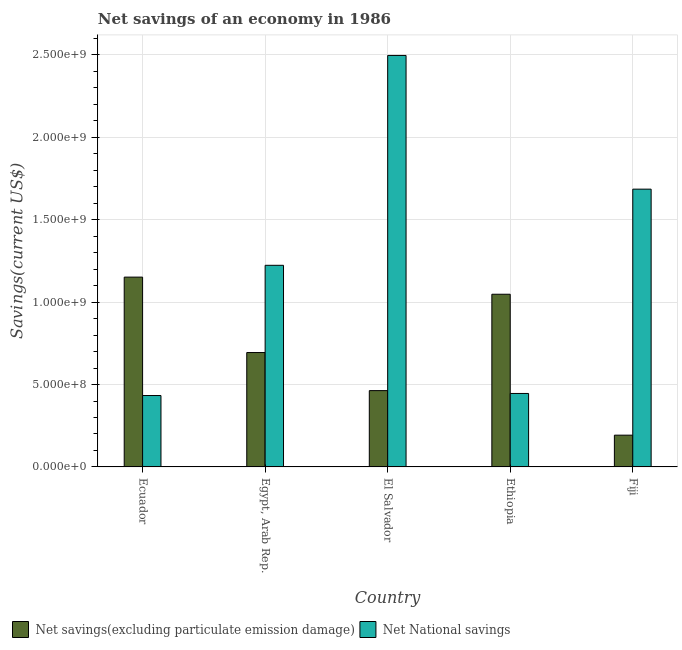How many groups of bars are there?
Keep it short and to the point. 5. How many bars are there on the 1st tick from the left?
Your response must be concise. 2. How many bars are there on the 2nd tick from the right?
Provide a short and direct response. 2. What is the label of the 4th group of bars from the left?
Provide a short and direct response. Ethiopia. In how many cases, is the number of bars for a given country not equal to the number of legend labels?
Your answer should be compact. 0. What is the net national savings in Ecuador?
Ensure brevity in your answer.  4.33e+08. Across all countries, what is the maximum net savings(excluding particulate emission damage)?
Ensure brevity in your answer.  1.15e+09. Across all countries, what is the minimum net national savings?
Your response must be concise. 4.33e+08. In which country was the net national savings maximum?
Offer a very short reply. El Salvador. In which country was the net savings(excluding particulate emission damage) minimum?
Offer a terse response. Fiji. What is the total net savings(excluding particulate emission damage) in the graph?
Keep it short and to the point. 3.55e+09. What is the difference between the net national savings in Egypt, Arab Rep. and that in El Salvador?
Provide a succinct answer. -1.27e+09. What is the difference between the net national savings in Fiji and the net savings(excluding particulate emission damage) in Egypt, Arab Rep.?
Offer a terse response. 9.91e+08. What is the average net national savings per country?
Provide a short and direct response. 1.26e+09. What is the difference between the net savings(excluding particulate emission damage) and net national savings in El Salvador?
Your answer should be very brief. -2.03e+09. What is the ratio of the net savings(excluding particulate emission damage) in Egypt, Arab Rep. to that in Fiji?
Your answer should be very brief. 3.6. Is the net national savings in Egypt, Arab Rep. less than that in Ethiopia?
Provide a short and direct response. No. What is the difference between the highest and the second highest net savings(excluding particulate emission damage)?
Provide a short and direct response. 1.04e+08. What is the difference between the highest and the lowest net savings(excluding particulate emission damage)?
Ensure brevity in your answer.  9.59e+08. In how many countries, is the net national savings greater than the average net national savings taken over all countries?
Keep it short and to the point. 2. What does the 2nd bar from the left in El Salvador represents?
Offer a very short reply. Net National savings. What does the 2nd bar from the right in Ecuador represents?
Your answer should be very brief. Net savings(excluding particulate emission damage). Are all the bars in the graph horizontal?
Your answer should be very brief. No. Are the values on the major ticks of Y-axis written in scientific E-notation?
Give a very brief answer. Yes. Where does the legend appear in the graph?
Your answer should be compact. Bottom left. What is the title of the graph?
Provide a short and direct response. Net savings of an economy in 1986. What is the label or title of the Y-axis?
Provide a short and direct response. Savings(current US$). What is the Savings(current US$) in Net savings(excluding particulate emission damage) in Ecuador?
Your answer should be very brief. 1.15e+09. What is the Savings(current US$) of Net National savings in Ecuador?
Offer a terse response. 4.33e+08. What is the Savings(current US$) of Net savings(excluding particulate emission damage) in Egypt, Arab Rep.?
Ensure brevity in your answer.  6.94e+08. What is the Savings(current US$) in Net National savings in Egypt, Arab Rep.?
Provide a short and direct response. 1.22e+09. What is the Savings(current US$) of Net savings(excluding particulate emission damage) in El Salvador?
Keep it short and to the point. 4.63e+08. What is the Savings(current US$) of Net National savings in El Salvador?
Your answer should be compact. 2.50e+09. What is the Savings(current US$) of Net savings(excluding particulate emission damage) in Ethiopia?
Your answer should be very brief. 1.05e+09. What is the Savings(current US$) in Net National savings in Ethiopia?
Offer a terse response. 4.46e+08. What is the Savings(current US$) in Net savings(excluding particulate emission damage) in Fiji?
Your answer should be very brief. 1.93e+08. What is the Savings(current US$) in Net National savings in Fiji?
Offer a very short reply. 1.69e+09. Across all countries, what is the maximum Savings(current US$) of Net savings(excluding particulate emission damage)?
Provide a succinct answer. 1.15e+09. Across all countries, what is the maximum Savings(current US$) of Net National savings?
Offer a terse response. 2.50e+09. Across all countries, what is the minimum Savings(current US$) of Net savings(excluding particulate emission damage)?
Ensure brevity in your answer.  1.93e+08. Across all countries, what is the minimum Savings(current US$) in Net National savings?
Your answer should be very brief. 4.33e+08. What is the total Savings(current US$) of Net savings(excluding particulate emission damage) in the graph?
Your answer should be compact. 3.55e+09. What is the total Savings(current US$) of Net National savings in the graph?
Provide a short and direct response. 6.28e+09. What is the difference between the Savings(current US$) in Net savings(excluding particulate emission damage) in Ecuador and that in Egypt, Arab Rep.?
Provide a succinct answer. 4.58e+08. What is the difference between the Savings(current US$) in Net National savings in Ecuador and that in Egypt, Arab Rep.?
Offer a terse response. -7.90e+08. What is the difference between the Savings(current US$) in Net savings(excluding particulate emission damage) in Ecuador and that in El Salvador?
Provide a short and direct response. 6.89e+08. What is the difference between the Savings(current US$) in Net National savings in Ecuador and that in El Salvador?
Ensure brevity in your answer.  -2.06e+09. What is the difference between the Savings(current US$) of Net savings(excluding particulate emission damage) in Ecuador and that in Ethiopia?
Offer a terse response. 1.04e+08. What is the difference between the Savings(current US$) of Net National savings in Ecuador and that in Ethiopia?
Ensure brevity in your answer.  -1.25e+07. What is the difference between the Savings(current US$) in Net savings(excluding particulate emission damage) in Ecuador and that in Fiji?
Give a very brief answer. 9.59e+08. What is the difference between the Savings(current US$) of Net National savings in Ecuador and that in Fiji?
Offer a terse response. -1.25e+09. What is the difference between the Savings(current US$) of Net savings(excluding particulate emission damage) in Egypt, Arab Rep. and that in El Salvador?
Offer a very short reply. 2.31e+08. What is the difference between the Savings(current US$) in Net National savings in Egypt, Arab Rep. and that in El Salvador?
Ensure brevity in your answer.  -1.27e+09. What is the difference between the Savings(current US$) in Net savings(excluding particulate emission damage) in Egypt, Arab Rep. and that in Ethiopia?
Ensure brevity in your answer.  -3.54e+08. What is the difference between the Savings(current US$) in Net National savings in Egypt, Arab Rep. and that in Ethiopia?
Your response must be concise. 7.78e+08. What is the difference between the Savings(current US$) in Net savings(excluding particulate emission damage) in Egypt, Arab Rep. and that in Fiji?
Your answer should be compact. 5.01e+08. What is the difference between the Savings(current US$) in Net National savings in Egypt, Arab Rep. and that in Fiji?
Offer a terse response. -4.62e+08. What is the difference between the Savings(current US$) of Net savings(excluding particulate emission damage) in El Salvador and that in Ethiopia?
Ensure brevity in your answer.  -5.85e+08. What is the difference between the Savings(current US$) of Net National savings in El Salvador and that in Ethiopia?
Your response must be concise. 2.05e+09. What is the difference between the Savings(current US$) of Net savings(excluding particulate emission damage) in El Salvador and that in Fiji?
Provide a short and direct response. 2.70e+08. What is the difference between the Savings(current US$) of Net National savings in El Salvador and that in Fiji?
Make the answer very short. 8.11e+08. What is the difference between the Savings(current US$) of Net savings(excluding particulate emission damage) in Ethiopia and that in Fiji?
Provide a succinct answer. 8.55e+08. What is the difference between the Savings(current US$) in Net National savings in Ethiopia and that in Fiji?
Offer a terse response. -1.24e+09. What is the difference between the Savings(current US$) in Net savings(excluding particulate emission damage) in Ecuador and the Savings(current US$) in Net National savings in Egypt, Arab Rep.?
Give a very brief answer. -7.17e+07. What is the difference between the Savings(current US$) in Net savings(excluding particulate emission damage) in Ecuador and the Savings(current US$) in Net National savings in El Salvador?
Your answer should be compact. -1.34e+09. What is the difference between the Savings(current US$) of Net savings(excluding particulate emission damage) in Ecuador and the Savings(current US$) of Net National savings in Ethiopia?
Ensure brevity in your answer.  7.06e+08. What is the difference between the Savings(current US$) of Net savings(excluding particulate emission damage) in Ecuador and the Savings(current US$) of Net National savings in Fiji?
Offer a terse response. -5.34e+08. What is the difference between the Savings(current US$) in Net savings(excluding particulate emission damage) in Egypt, Arab Rep. and the Savings(current US$) in Net National savings in El Salvador?
Ensure brevity in your answer.  -1.80e+09. What is the difference between the Savings(current US$) of Net savings(excluding particulate emission damage) in Egypt, Arab Rep. and the Savings(current US$) of Net National savings in Ethiopia?
Your response must be concise. 2.48e+08. What is the difference between the Savings(current US$) of Net savings(excluding particulate emission damage) in Egypt, Arab Rep. and the Savings(current US$) of Net National savings in Fiji?
Make the answer very short. -9.91e+08. What is the difference between the Savings(current US$) of Net savings(excluding particulate emission damage) in El Salvador and the Savings(current US$) of Net National savings in Ethiopia?
Make the answer very short. 1.73e+07. What is the difference between the Savings(current US$) of Net savings(excluding particulate emission damage) in El Salvador and the Savings(current US$) of Net National savings in Fiji?
Provide a succinct answer. -1.22e+09. What is the difference between the Savings(current US$) of Net savings(excluding particulate emission damage) in Ethiopia and the Savings(current US$) of Net National savings in Fiji?
Make the answer very short. -6.38e+08. What is the average Savings(current US$) of Net savings(excluding particulate emission damage) per country?
Provide a succinct answer. 7.10e+08. What is the average Savings(current US$) in Net National savings per country?
Offer a terse response. 1.26e+09. What is the difference between the Savings(current US$) in Net savings(excluding particulate emission damage) and Savings(current US$) in Net National savings in Ecuador?
Keep it short and to the point. 7.18e+08. What is the difference between the Savings(current US$) of Net savings(excluding particulate emission damage) and Savings(current US$) of Net National savings in Egypt, Arab Rep.?
Make the answer very short. -5.29e+08. What is the difference between the Savings(current US$) of Net savings(excluding particulate emission damage) and Savings(current US$) of Net National savings in El Salvador?
Ensure brevity in your answer.  -2.03e+09. What is the difference between the Savings(current US$) in Net savings(excluding particulate emission damage) and Savings(current US$) in Net National savings in Ethiopia?
Keep it short and to the point. 6.02e+08. What is the difference between the Savings(current US$) in Net savings(excluding particulate emission damage) and Savings(current US$) in Net National savings in Fiji?
Provide a succinct answer. -1.49e+09. What is the ratio of the Savings(current US$) of Net savings(excluding particulate emission damage) in Ecuador to that in Egypt, Arab Rep.?
Keep it short and to the point. 1.66. What is the ratio of the Savings(current US$) in Net National savings in Ecuador to that in Egypt, Arab Rep.?
Keep it short and to the point. 0.35. What is the ratio of the Savings(current US$) in Net savings(excluding particulate emission damage) in Ecuador to that in El Salvador?
Ensure brevity in your answer.  2.49. What is the ratio of the Savings(current US$) of Net National savings in Ecuador to that in El Salvador?
Your answer should be very brief. 0.17. What is the ratio of the Savings(current US$) of Net savings(excluding particulate emission damage) in Ecuador to that in Ethiopia?
Give a very brief answer. 1.1. What is the ratio of the Savings(current US$) of Net National savings in Ecuador to that in Ethiopia?
Your answer should be compact. 0.97. What is the ratio of the Savings(current US$) in Net savings(excluding particulate emission damage) in Ecuador to that in Fiji?
Provide a succinct answer. 5.98. What is the ratio of the Savings(current US$) in Net National savings in Ecuador to that in Fiji?
Ensure brevity in your answer.  0.26. What is the ratio of the Savings(current US$) of Net savings(excluding particulate emission damage) in Egypt, Arab Rep. to that in El Salvador?
Offer a terse response. 1.5. What is the ratio of the Savings(current US$) in Net National savings in Egypt, Arab Rep. to that in El Salvador?
Ensure brevity in your answer.  0.49. What is the ratio of the Savings(current US$) in Net savings(excluding particulate emission damage) in Egypt, Arab Rep. to that in Ethiopia?
Your answer should be compact. 0.66. What is the ratio of the Savings(current US$) in Net National savings in Egypt, Arab Rep. to that in Ethiopia?
Keep it short and to the point. 2.74. What is the ratio of the Savings(current US$) of Net savings(excluding particulate emission damage) in Egypt, Arab Rep. to that in Fiji?
Ensure brevity in your answer.  3.6. What is the ratio of the Savings(current US$) of Net National savings in Egypt, Arab Rep. to that in Fiji?
Your answer should be compact. 0.73. What is the ratio of the Savings(current US$) of Net savings(excluding particulate emission damage) in El Salvador to that in Ethiopia?
Your answer should be compact. 0.44. What is the ratio of the Savings(current US$) in Net National savings in El Salvador to that in Ethiopia?
Provide a succinct answer. 5.6. What is the ratio of the Savings(current US$) in Net savings(excluding particulate emission damage) in El Salvador to that in Fiji?
Your response must be concise. 2.4. What is the ratio of the Savings(current US$) of Net National savings in El Salvador to that in Fiji?
Your answer should be compact. 1.48. What is the ratio of the Savings(current US$) in Net savings(excluding particulate emission damage) in Ethiopia to that in Fiji?
Keep it short and to the point. 5.44. What is the ratio of the Savings(current US$) in Net National savings in Ethiopia to that in Fiji?
Provide a short and direct response. 0.26. What is the difference between the highest and the second highest Savings(current US$) in Net savings(excluding particulate emission damage)?
Offer a terse response. 1.04e+08. What is the difference between the highest and the second highest Savings(current US$) in Net National savings?
Ensure brevity in your answer.  8.11e+08. What is the difference between the highest and the lowest Savings(current US$) of Net savings(excluding particulate emission damage)?
Your answer should be very brief. 9.59e+08. What is the difference between the highest and the lowest Savings(current US$) of Net National savings?
Offer a very short reply. 2.06e+09. 